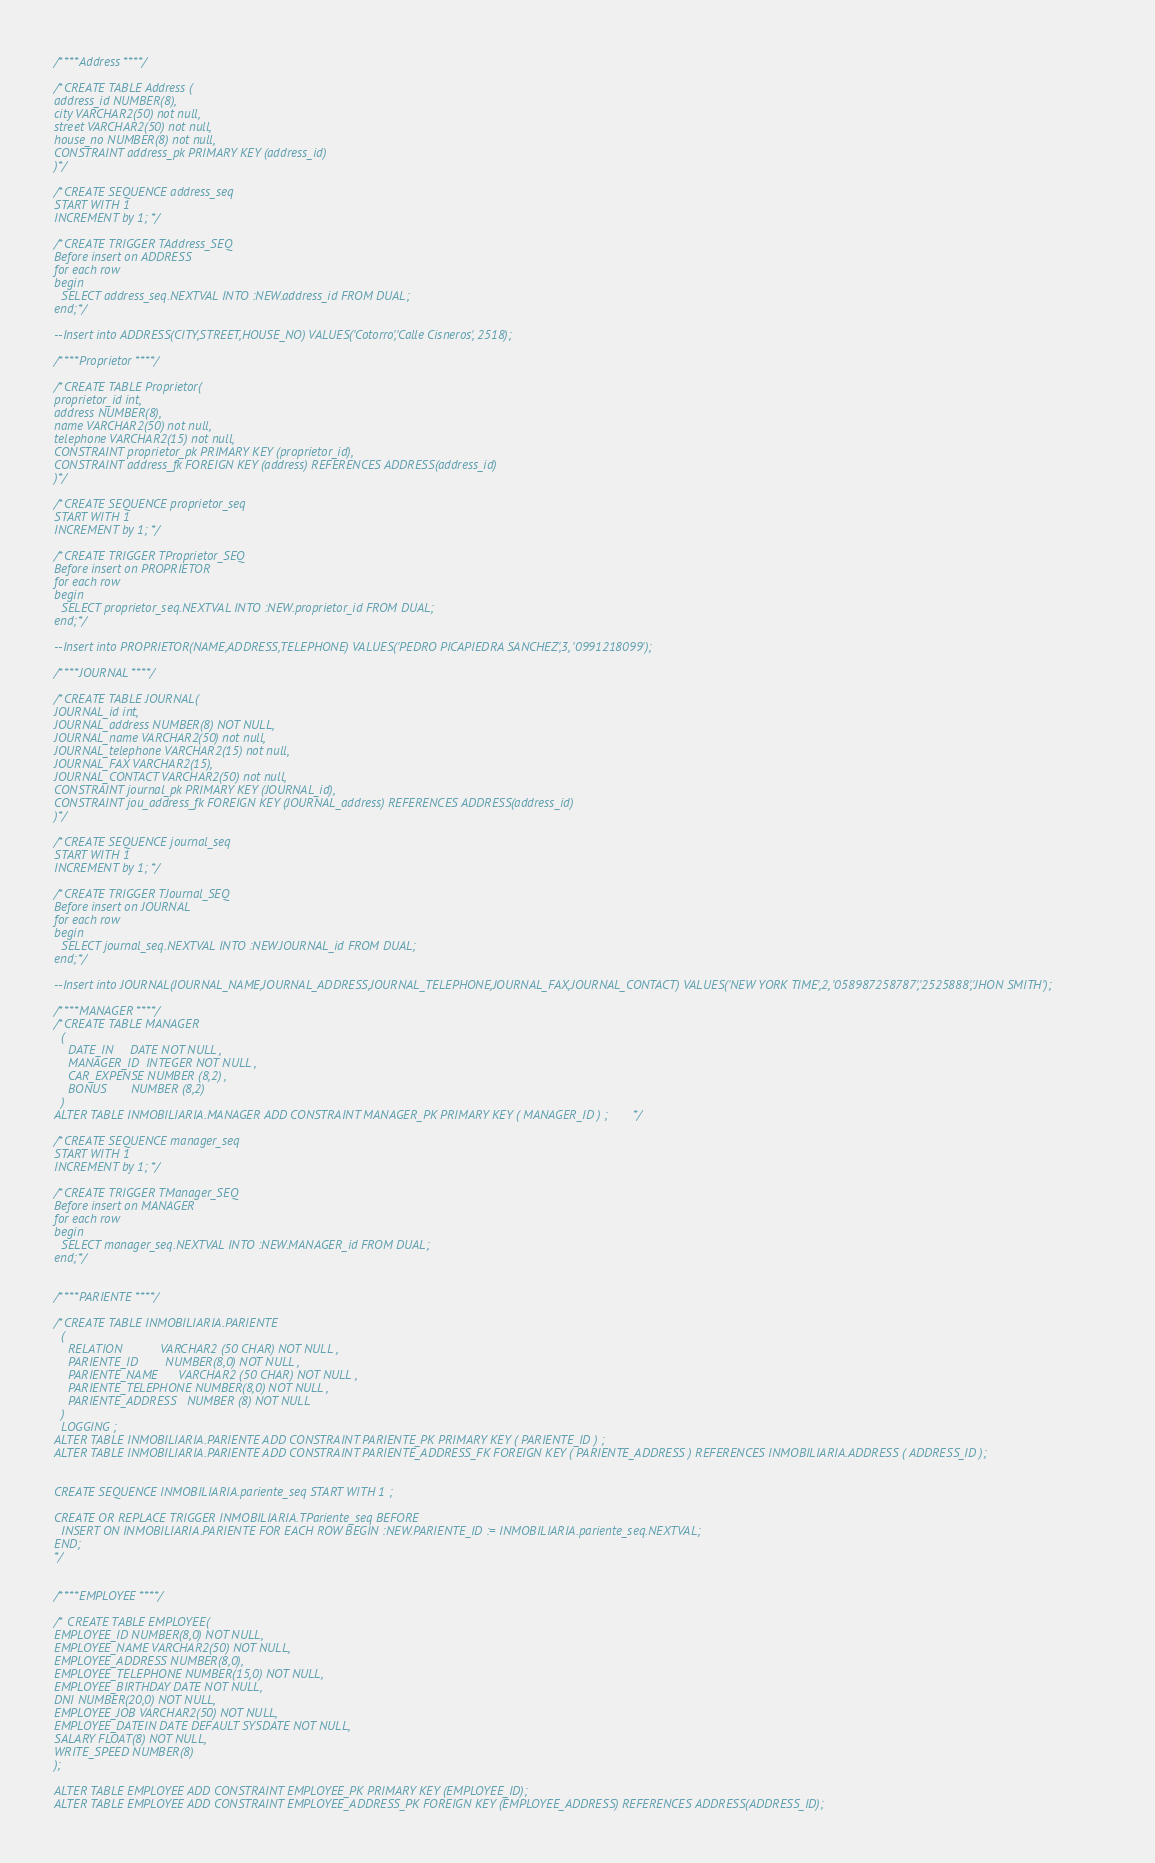<code> <loc_0><loc_0><loc_500><loc_500><_SQL_>/****Address****/

/*CREATE TABLE Address (
address_id NUMBER(8),
city VARCHAR2(50) not null,
street VARCHAR2(50) not null,
house_no NUMBER(8) not null,
CONSTRAINT address_pk PRIMARY KEY (address_id)
)*/

/*CREATE SEQUENCE address_seq 
START WITH 1
INCREMENT by 1;*/

/*CREATE TRIGGER TAddress_SEQ
Before insert on ADDRESS
for each row
begin
  SELECT address_seq.NEXTVAL INTO :NEW.address_id FROM DUAL;
end;*/

--Insert into ADDRESS(CITY,STREET,HOUSE_NO) VALUES('Cotorro','Calle Cisneros', 2518);

/****Proprietor****/

/*CREATE TABLE Proprietor(
proprietor_id int,
address NUMBER(8),
name VARCHAR2(50) not null,
telephone VARCHAR2(15) not null,
CONSTRAINT proprietor_pk PRIMARY KEY (proprietor_id),
CONSTRAINT address_fk FOREIGN KEY (address) REFERENCES ADDRESS(address_id) 
)*/

/*CREATE SEQUENCE proprietor_seq 
START WITH 1
INCREMENT by 1;*/

/*CREATE TRIGGER TProprietor_SEQ
Before insert on PROPRIETOR
for each row
begin
  SELECT proprietor_seq.NEXTVAL INTO :NEW.proprietor_id FROM DUAL;
end;*/

--Insert into PROPRIETOR(NAME,ADDRESS,TELEPHONE) VALUES('PEDRO PICAPIEDRA SANCHEZ',3, '0991218099');

/****JOURNAL****/

/*CREATE TABLE JOURNAL(
JOURNAL_id int,
JOURNAL_address NUMBER(8) NOT NULL,
JOURNAL_name VARCHAR2(50) not null,
JOURNAL_telephone VARCHAR2(15) not null,
JOURNAL_FAX VARCHAR2(15),
JOURNAL_CONTACT VARCHAR2(50) not null,
CONSTRAINT journal_pk PRIMARY KEY (JOURNAL_id),
CONSTRAINT jou_address_fk FOREIGN KEY (JOURNAL_address) REFERENCES ADDRESS(address_id) 
)*/

/*CREATE SEQUENCE journal_seq 
START WITH 1
INCREMENT by 1;*/

/*CREATE TRIGGER TJournal_SEQ
Before insert on JOURNAL
for each row
begin
  SELECT journal_seq.NEXTVAL INTO :NEW.JOURNAL_id FROM DUAL;
end;*/

--Insert into JOURNAL(JOURNAL_NAME,JOURNAL_ADDRESS,JOURNAL_TELEPHONE,JOURNAL_FAX,JOURNAL_CONTACT) VALUES('NEW YORK TIME',2, '058987258787','2525888','JHON SMITH');

/****MANAGER****/
/*CREATE TABLE MANAGER
  (
    DATE_IN     DATE NOT NULL ,
    MANAGER_ID  INTEGER NOT NULL ,
    CAR_EXPENSE NUMBER (8,2) ,
    BONUS       NUMBER (8,2)
  )
ALTER TABLE INMOBILIARIA.MANAGER ADD CONSTRAINT MANAGER_PK PRIMARY KEY ( MANAGER_ID ) ;*/

/*CREATE SEQUENCE manager_seq 
START WITH 1
INCREMENT by 1;*/

/*CREATE TRIGGER TManager_SEQ
Before insert on MANAGER
for each row
begin
  SELECT manager_seq.NEXTVAL INTO :NEW.MANAGER_id FROM DUAL;
end;*/


/****PARIENTE****/

/*CREATE TABLE INMOBILIARIA.PARIENTE
  (
    RELATION           VARCHAR2 (50 CHAR) NOT NULL ,
    PARIENTE_ID        NUMBER(8,0) NOT NULL ,
    PARIENTE_NAME      VARCHAR2 (50 CHAR) NOT NULL ,
    PARIENTE_TELEPHONE NUMBER(8,0) NOT NULL ,
    PARIENTE_ADDRESS   NUMBER (8) NOT NULL
  )
  LOGGING ;
ALTER TABLE INMOBILIARIA.PARIENTE ADD CONSTRAINT PARIENTE_PK PRIMARY KEY ( PARIENTE_ID ) ;
ALTER TABLE INMOBILIARIA.PARIENTE ADD CONSTRAINT PARIENTE_ADDRESS_FK FOREIGN KEY ( PARIENTE_ADDRESS ) REFERENCES INMOBILIARIA.ADDRESS ( ADDRESS_ID );


CREATE SEQUENCE INMOBILIARIA.pariente_seq START WITH 1 ;

CREATE OR REPLACE TRIGGER INMOBILIARIA.TPariente_seq BEFORE
  INSERT ON INMOBILIARIA.PARIENTE FOR EACH ROW BEGIN :NEW.PARIENTE_ID := INMOBILIARIA.pariente_seq.NEXTVAL;
END;
*/


/****EMPLOYEE****/

/* CREATE TABLE EMPLOYEE(
EMPLOYEE_ID NUMBER(8,0) NOT NULL,
EMPLOYEE_NAME VARCHAR2(50) NOT NULL,
EMPLOYEE_ADDRESS NUMBER(8,0),
EMPLOYEE_TELEPHONE NUMBER(15,0) NOT NULL,
EMPLOYEE_BIRTHDAY DATE NOT NULL,
DNI NUMBER(20,0) NOT NULL,
EMPLOYEE_JOB VARCHAR2(50) NOT NULL,
EMPLOYEE_DATEIN DATE DEFAULT SYSDATE NOT NULL,
SALARY FLOAT(8) NOT NULL,
WRITE_SPEED NUMBER(8)
);

ALTER TABLE EMPLOYEE ADD CONSTRAINT EMPLOYEE_PK PRIMARY KEY (EMPLOYEE_ID);
ALTER TABLE EMPLOYEE ADD CONSTRAINT EMPLOYEE_ADDRESS_PK FOREIGN KEY (EMPLOYEE_ADDRESS) REFERENCES ADDRESS(ADDRESS_ID);</code> 